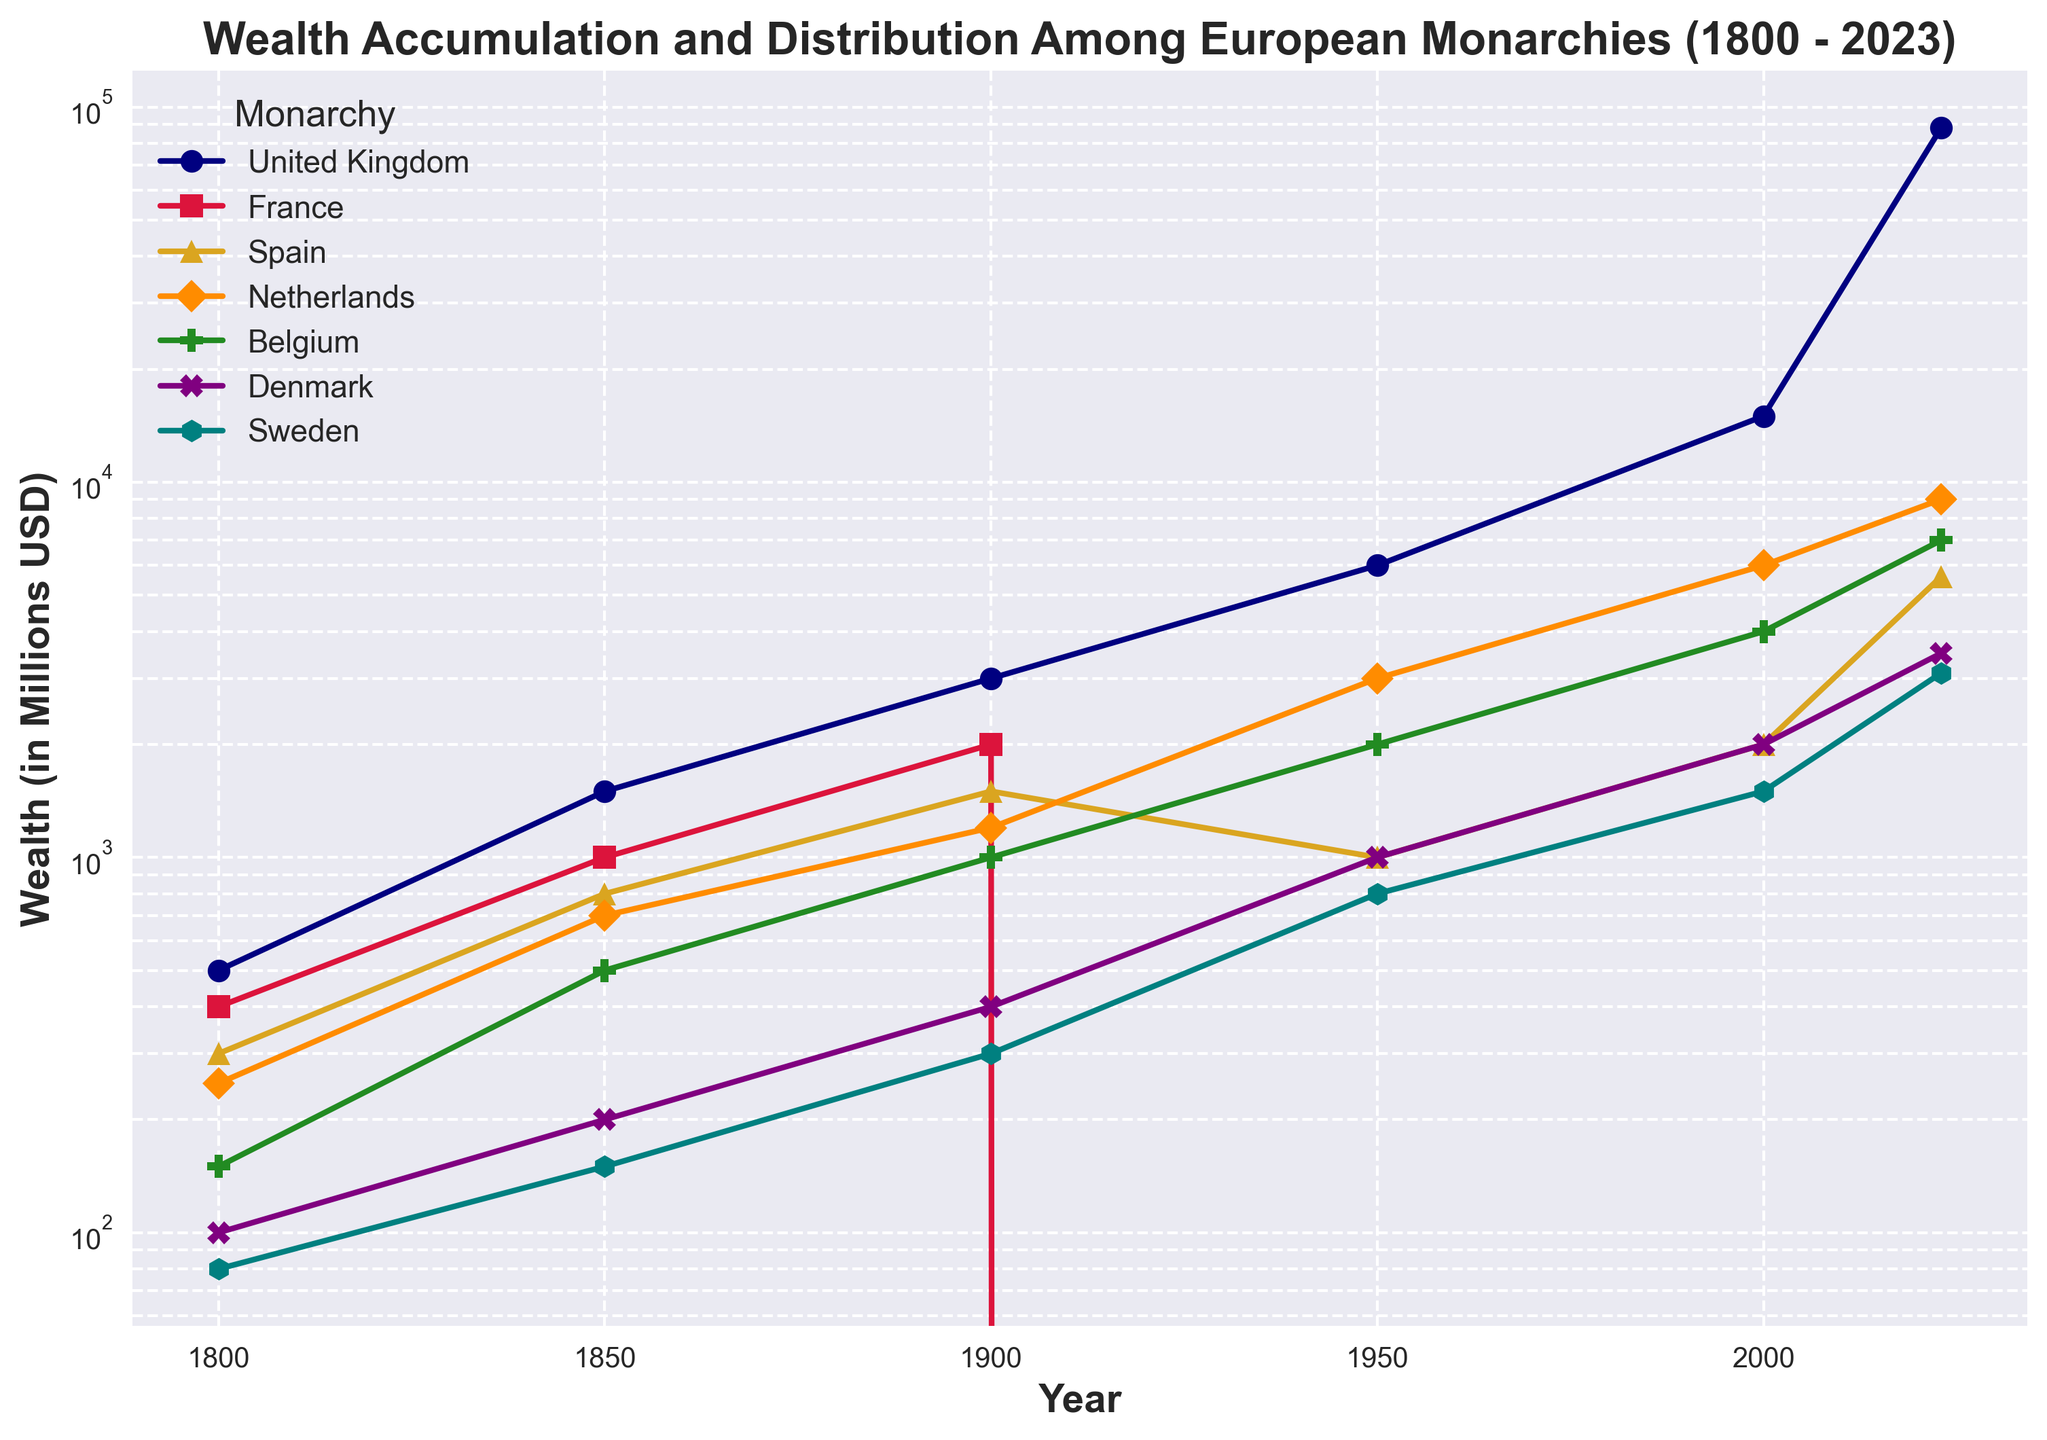Which monarchy had its wealth reach the highest amount in 2023? To find the monarchy with the highest wealth in 2023, look for the highest value on the y-axis at the year 2023. The United Kingdom is marked with the highest point.
Answer: United Kingdom How did the wealth of France change in the 1950s compared to 1900? Comparing the wealth values of France in 1900 and 1950 by looking at the points on the y-axis, it goes from 2000 million USD in 1900 to 0 in 1950.
Answer: Decreased to 0 Among United Kingdom, Spain, and Belgium in 2023, which monarchy had the smallest wealth? Compare the y-axis values for these three monarchies at 2023. Spain's wealth is marked lower than United Kingdom and Belgium.
Answer: Spain What is the difference in wealth between the Netherlands and Denmark in 2023? The y-axis values for the Netherlands and Denmark in 2023 are 9000 million USD and 3500 million USD respectively. Subtract Denmark's wealth from the Netherlands’.
Answer: 5500 million USD What color represents the monarchy with the highest wealth in 1800? In 1800, the United Kingdom had the highest wealth. The color corresponding to the United Kingdom is navy.
Answer: Navy Which monarchy experienced the biggest increase in wealth between 2000 and 2023? Calculate the difference in wealth for each monarchy between 2000 and 2023 and identify the largest increase. The United Kingdom increased from 15000 to 88000 million USD.
Answer: United Kingdom Does Belgium's wealth increase or decrease from 1950 to 2023? Check the values in 1950 and 2023; Belgium’s wealth goes from 2000 million USD in 1950 to 7000 million USD in 2023.
Answer: Increase What trend can be observed about Sweden’s wealth from 1800 to 2023? Observe the trend line for Sweden; it consistently increases over time.
Answer: Increasing trend 